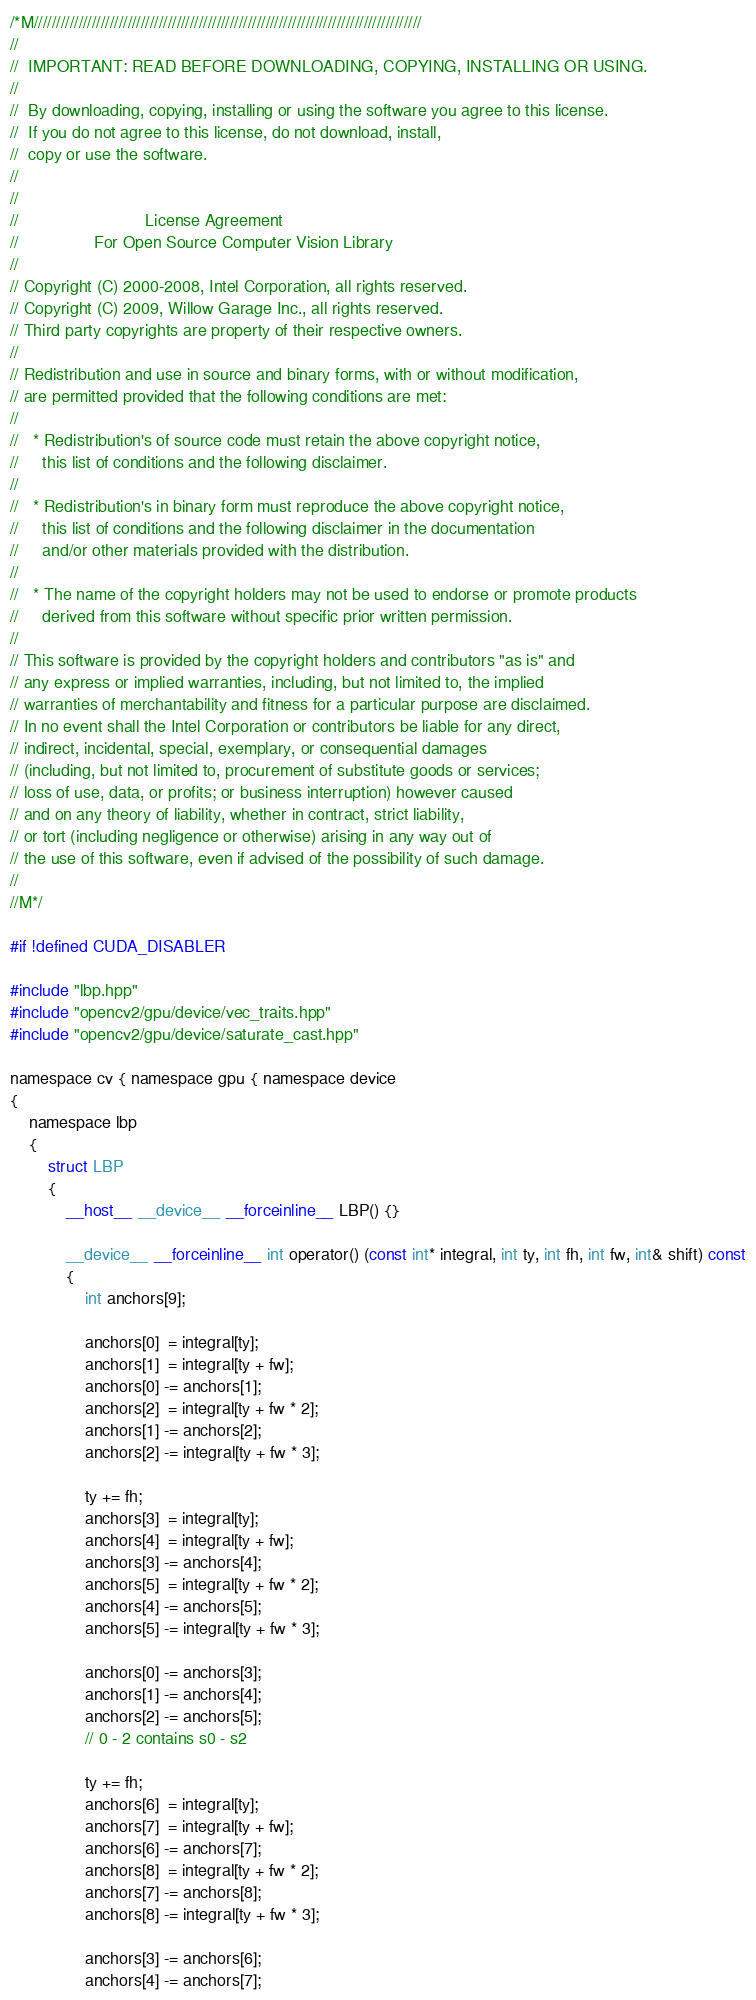<code> <loc_0><loc_0><loc_500><loc_500><_Cuda_>/*M///////////////////////////////////////////////////////////////////////////////////////
//
//  IMPORTANT: READ BEFORE DOWNLOADING, COPYING, INSTALLING OR USING.
//
//  By downloading, copying, installing or using the software you agree to this license.
//  If you do not agree to this license, do not download, install,
//  copy or use the software.
//
//
//                           License Agreement
//                For Open Source Computer Vision Library
//
// Copyright (C) 2000-2008, Intel Corporation, all rights reserved.
// Copyright (C) 2009, Willow Garage Inc., all rights reserved.
// Third party copyrights are property of their respective owners.
//
// Redistribution and use in source and binary forms, with or without modification,
// are permitted provided that the following conditions are met:
//
//   * Redistribution's of source code must retain the above copyright notice,
//     this list of conditions and the following disclaimer.
//
//   * Redistribution's in binary form must reproduce the above copyright notice,
//     this list of conditions and the following disclaimer in the documentation
//     and/or other materials provided with the distribution.
//
//   * The name of the copyright holders may not be used to endorse or promote products
//     derived from this software without specific prior written permission.
//
// This software is provided by the copyright holders and contributors "as is" and
// any express or implied warranties, including, but not limited to, the implied
// warranties of merchantability and fitness for a particular purpose are disclaimed.
// In no event shall the Intel Corporation or contributors be liable for any direct,
// indirect, incidental, special, exemplary, or consequential damages
// (including, but not limited to, procurement of substitute goods or services;
// loss of use, data, or profits; or business interruption) however caused
// and on any theory of liability, whether in contract, strict liability,
// or tort (including negligence or otherwise) arising in any way out of
// the use of this software, even if advised of the possibility of such damage.
//
//M*/

#if !defined CUDA_DISABLER

#include "lbp.hpp"
#include "opencv2/gpu/device/vec_traits.hpp"
#include "opencv2/gpu/device/saturate_cast.hpp"

namespace cv { namespace gpu { namespace device
{
    namespace lbp
    {
        struct LBP
        {
            __host__ __device__ __forceinline__ LBP() {}

            __device__ __forceinline__ int operator() (const int* integral, int ty, int fh, int fw, int& shift) const
            {
                int anchors[9];

                anchors[0]  = integral[ty];
                anchors[1]  = integral[ty + fw];
                anchors[0] -= anchors[1];
                anchors[2]  = integral[ty + fw * 2];
                anchors[1] -= anchors[2];
                anchors[2] -= integral[ty + fw * 3];

                ty += fh;
                anchors[3]  = integral[ty];
                anchors[4]  = integral[ty + fw];
                anchors[3] -= anchors[4];
                anchors[5]  = integral[ty + fw * 2];
                anchors[4] -= anchors[5];
                anchors[5] -= integral[ty + fw * 3];

                anchors[0] -= anchors[3];
                anchors[1] -= anchors[4];
                anchors[2] -= anchors[5];
                // 0 - 2 contains s0 - s2

                ty += fh;
                anchors[6]  = integral[ty];
                anchors[7]  = integral[ty + fw];
                anchors[6] -= anchors[7];
                anchors[8]  = integral[ty + fw * 2];
                anchors[7] -= anchors[8];
                anchors[8] -= integral[ty + fw * 3];

                anchors[3] -= anchors[6];
                anchors[4] -= anchors[7];</code> 